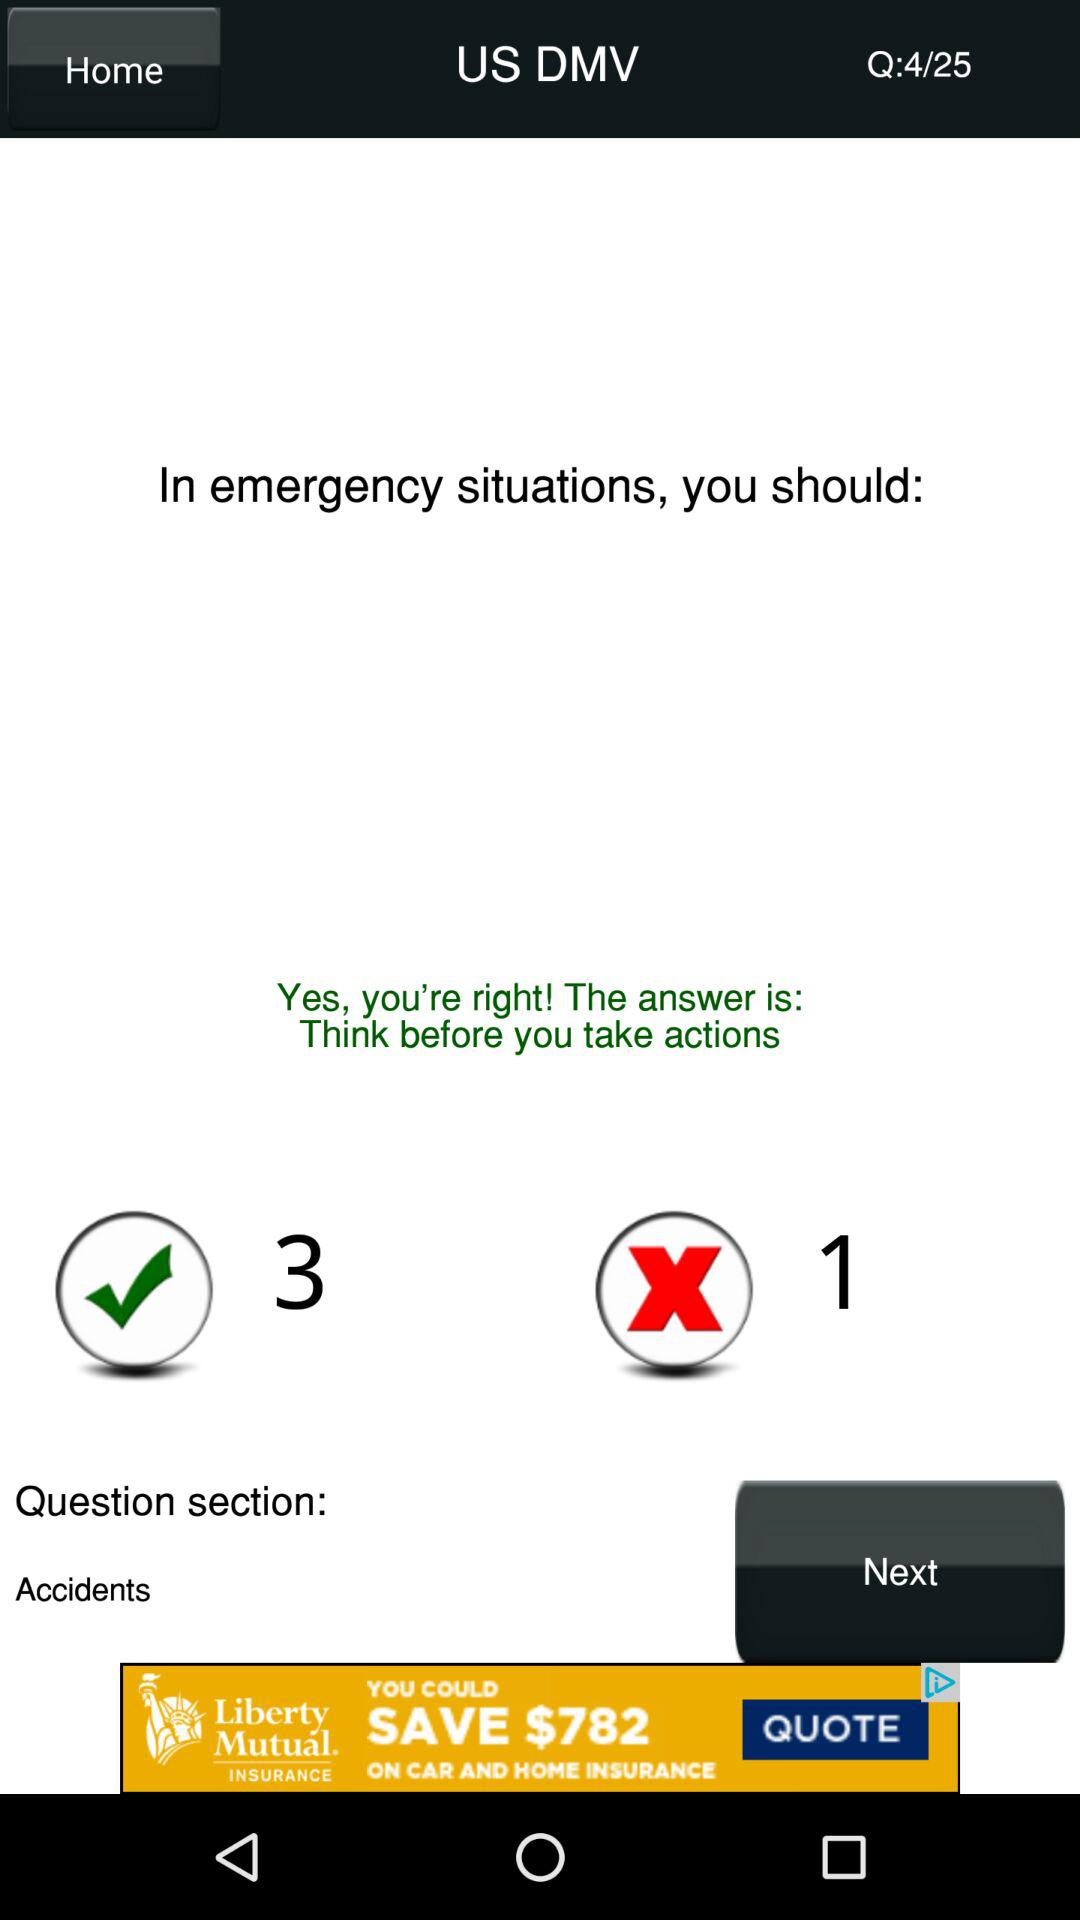Was my answer correct? Your answer was correct. 